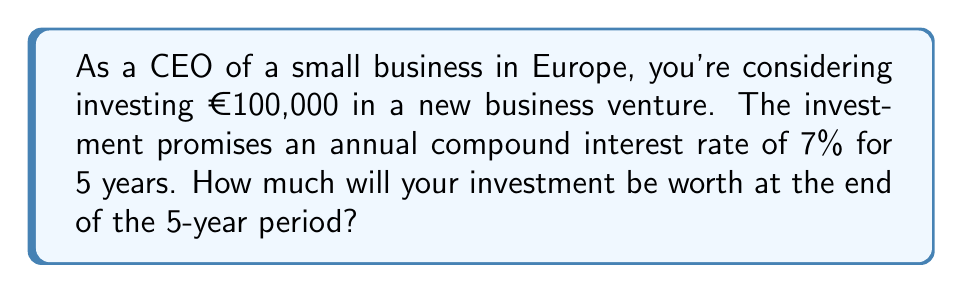Can you solve this math problem? To solve this problem, we'll use the compound interest formula:

$$A = P(1 + r)^n$$

Where:
$A$ = Final amount
$P$ = Principal (initial investment)
$r$ = Annual interest rate (in decimal form)
$n$ = Number of years

Given:
$P = €100,000$
$r = 7\% = 0.07$
$n = 5$ years

Let's substitute these values into the formula:

$$A = 100,000(1 + 0.07)^5$$

Now, let's calculate step by step:

1) First, add 1 to the interest rate:
   $1 + 0.07 = 1.07$

2) Then, raise this to the power of 5:
   $1.07^5 \approx 1.4025547$

3) Finally, multiply by the principal:
   $100,000 \times 1.4025547 \approx 140,255.47$

Therefore, after 5 years, the investment will be worth approximately €140,255.47.
Answer: €140,255.47 